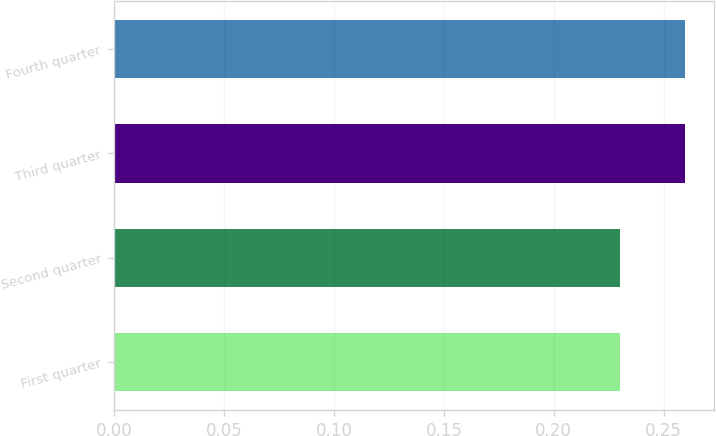<chart> <loc_0><loc_0><loc_500><loc_500><bar_chart><fcel>First quarter<fcel>Second quarter<fcel>Third quarter<fcel>Fourth quarter<nl><fcel>0.23<fcel>0.23<fcel>0.26<fcel>0.26<nl></chart> 